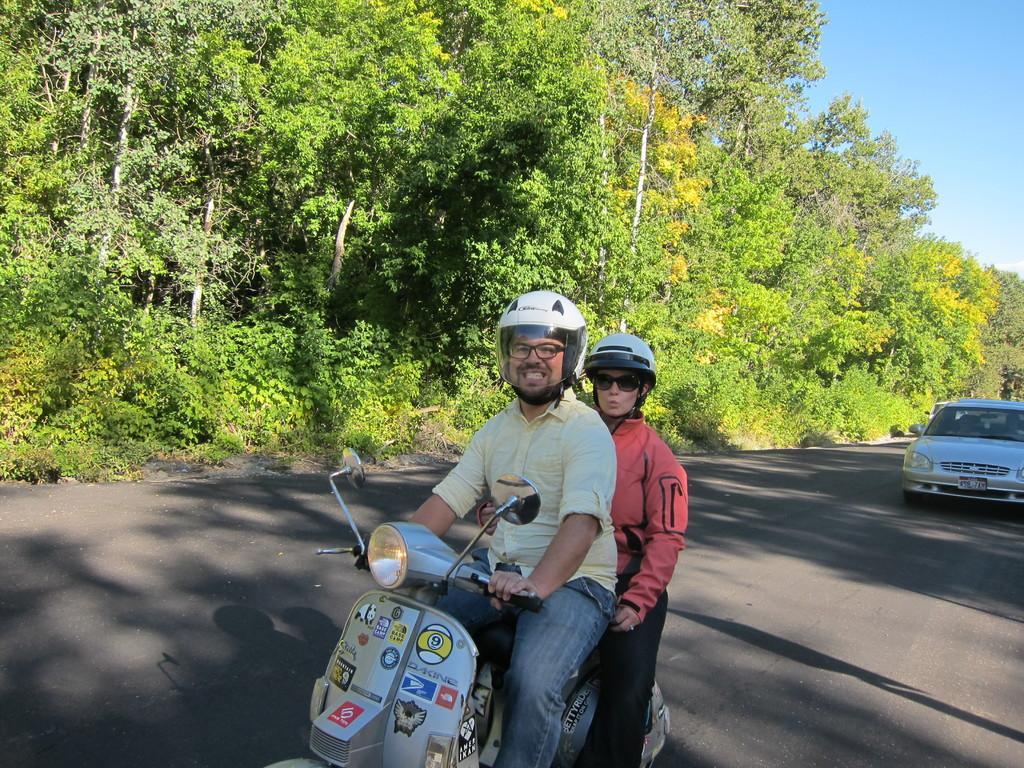In one or two sentences, can you explain what this image depicts? In this picture outside of the city. The two persons are riding a scooter. They are wearing a helmet. They are wearing spectacles. They are smiling. We can see in background tree and sky. 